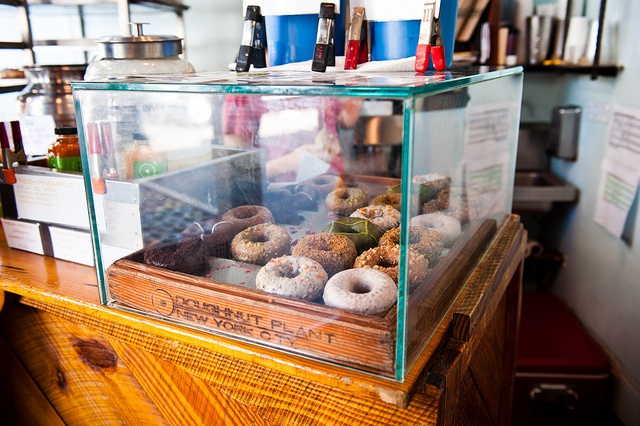Describe the objects in this image and their specific colors. I can see donut in black, gray, and darkgray tones, bottle in black, lightgray, darkgray, and gray tones, donut in black, lightgray, pink, darkgray, and gray tones, bottle in black, maroon, gray, and darkgreen tones, and sink in black and gray tones in this image. 